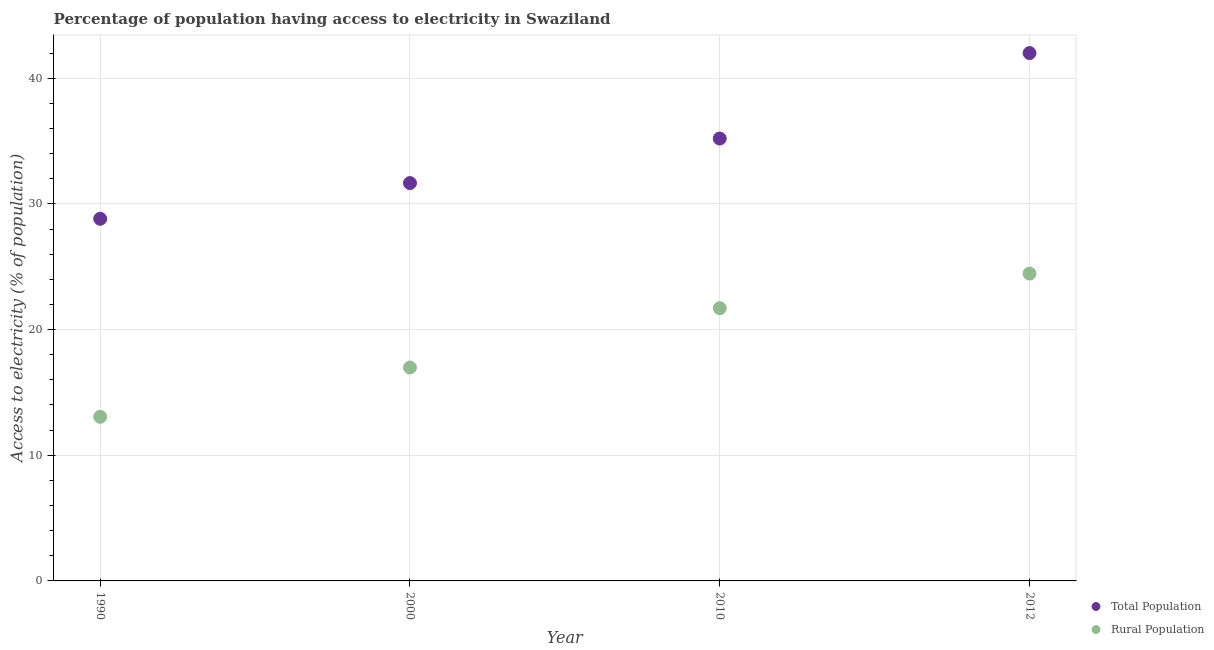How many different coloured dotlines are there?
Your answer should be compact. 2. What is the percentage of population having access to electricity in 1990?
Offer a very short reply. 28.82. Across all years, what is the maximum percentage of rural population having access to electricity?
Provide a short and direct response. 24.45. Across all years, what is the minimum percentage of rural population having access to electricity?
Ensure brevity in your answer.  13.06. In which year was the percentage of population having access to electricity maximum?
Keep it short and to the point. 2012. In which year was the percentage of rural population having access to electricity minimum?
Make the answer very short. 1990. What is the total percentage of population having access to electricity in the graph?
Your response must be concise. 137.67. What is the difference between the percentage of population having access to electricity in 2010 and that in 2012?
Offer a very short reply. -6.8. What is the difference between the percentage of rural population having access to electricity in 2010 and the percentage of population having access to electricity in 2012?
Keep it short and to the point. -20.3. What is the average percentage of population having access to electricity per year?
Offer a very short reply. 34.42. In the year 2012, what is the difference between the percentage of population having access to electricity and percentage of rural population having access to electricity?
Offer a terse response. 17.55. In how many years, is the percentage of population having access to electricity greater than 34 %?
Your answer should be compact. 2. What is the ratio of the percentage of population having access to electricity in 1990 to that in 2012?
Provide a succinct answer. 0.69. What is the difference between the highest and the second highest percentage of population having access to electricity?
Provide a short and direct response. 6.8. What is the difference between the highest and the lowest percentage of rural population having access to electricity?
Your response must be concise. 11.39. In how many years, is the percentage of population having access to electricity greater than the average percentage of population having access to electricity taken over all years?
Your answer should be compact. 2. Is the sum of the percentage of population having access to electricity in 1990 and 2012 greater than the maximum percentage of rural population having access to electricity across all years?
Ensure brevity in your answer.  Yes. Is the percentage of population having access to electricity strictly less than the percentage of rural population having access to electricity over the years?
Give a very brief answer. No. How many dotlines are there?
Make the answer very short. 2. How many years are there in the graph?
Offer a terse response. 4. Are the values on the major ticks of Y-axis written in scientific E-notation?
Your answer should be very brief. No. How many legend labels are there?
Your answer should be compact. 2. What is the title of the graph?
Your response must be concise. Percentage of population having access to electricity in Swaziland. What is the label or title of the Y-axis?
Your answer should be compact. Access to electricity (% of population). What is the Access to electricity (% of population) in Total Population in 1990?
Your answer should be compact. 28.82. What is the Access to electricity (% of population) in Rural Population in 1990?
Provide a succinct answer. 13.06. What is the Access to electricity (% of population) in Total Population in 2000?
Make the answer very short. 31.66. What is the Access to electricity (% of population) of Rural Population in 2000?
Give a very brief answer. 16.98. What is the Access to electricity (% of population) of Total Population in 2010?
Your response must be concise. 35.2. What is the Access to electricity (% of population) of Rural Population in 2010?
Your response must be concise. 21.7. What is the Access to electricity (% of population) of Total Population in 2012?
Provide a succinct answer. 42. What is the Access to electricity (% of population) in Rural Population in 2012?
Your response must be concise. 24.45. Across all years, what is the maximum Access to electricity (% of population) of Rural Population?
Your answer should be very brief. 24.45. Across all years, what is the minimum Access to electricity (% of population) in Total Population?
Provide a succinct answer. 28.82. Across all years, what is the minimum Access to electricity (% of population) in Rural Population?
Your response must be concise. 13.06. What is the total Access to electricity (% of population) in Total Population in the graph?
Provide a short and direct response. 137.67. What is the total Access to electricity (% of population) of Rural Population in the graph?
Keep it short and to the point. 76.2. What is the difference between the Access to electricity (% of population) in Total Population in 1990 and that in 2000?
Provide a short and direct response. -2.84. What is the difference between the Access to electricity (% of population) of Rural Population in 1990 and that in 2000?
Offer a very short reply. -3.92. What is the difference between the Access to electricity (% of population) in Total Population in 1990 and that in 2010?
Provide a succinct answer. -6.38. What is the difference between the Access to electricity (% of population) in Rural Population in 1990 and that in 2010?
Give a very brief answer. -8.64. What is the difference between the Access to electricity (% of population) of Total Population in 1990 and that in 2012?
Provide a short and direct response. -13.18. What is the difference between the Access to electricity (% of population) of Rural Population in 1990 and that in 2012?
Offer a terse response. -11.39. What is the difference between the Access to electricity (% of population) in Total Population in 2000 and that in 2010?
Make the answer very short. -3.54. What is the difference between the Access to electricity (% of population) of Rural Population in 2000 and that in 2010?
Ensure brevity in your answer.  -4.72. What is the difference between the Access to electricity (% of population) of Total Population in 2000 and that in 2012?
Provide a short and direct response. -10.34. What is the difference between the Access to electricity (% of population) in Rural Population in 2000 and that in 2012?
Give a very brief answer. -7.47. What is the difference between the Access to electricity (% of population) in Total Population in 2010 and that in 2012?
Your answer should be very brief. -6.8. What is the difference between the Access to electricity (% of population) in Rural Population in 2010 and that in 2012?
Keep it short and to the point. -2.75. What is the difference between the Access to electricity (% of population) in Total Population in 1990 and the Access to electricity (% of population) in Rural Population in 2000?
Your answer should be very brief. 11.84. What is the difference between the Access to electricity (% of population) in Total Population in 1990 and the Access to electricity (% of population) in Rural Population in 2010?
Your response must be concise. 7.12. What is the difference between the Access to electricity (% of population) in Total Population in 1990 and the Access to electricity (% of population) in Rural Population in 2012?
Offer a very short reply. 4.36. What is the difference between the Access to electricity (% of population) of Total Population in 2000 and the Access to electricity (% of population) of Rural Population in 2010?
Your answer should be very brief. 9.96. What is the difference between the Access to electricity (% of population) in Total Population in 2000 and the Access to electricity (% of population) in Rural Population in 2012?
Your response must be concise. 7.2. What is the difference between the Access to electricity (% of population) of Total Population in 2010 and the Access to electricity (% of population) of Rural Population in 2012?
Ensure brevity in your answer.  10.75. What is the average Access to electricity (% of population) in Total Population per year?
Offer a terse response. 34.42. What is the average Access to electricity (% of population) of Rural Population per year?
Keep it short and to the point. 19.05. In the year 1990, what is the difference between the Access to electricity (% of population) in Total Population and Access to electricity (% of population) in Rural Population?
Provide a succinct answer. 15.76. In the year 2000, what is the difference between the Access to electricity (% of population) in Total Population and Access to electricity (% of population) in Rural Population?
Your response must be concise. 14.68. In the year 2012, what is the difference between the Access to electricity (% of population) of Total Population and Access to electricity (% of population) of Rural Population?
Offer a very short reply. 17.55. What is the ratio of the Access to electricity (% of population) of Total Population in 1990 to that in 2000?
Provide a succinct answer. 0.91. What is the ratio of the Access to electricity (% of population) of Rural Population in 1990 to that in 2000?
Your answer should be very brief. 0.77. What is the ratio of the Access to electricity (% of population) of Total Population in 1990 to that in 2010?
Provide a short and direct response. 0.82. What is the ratio of the Access to electricity (% of population) in Rural Population in 1990 to that in 2010?
Your response must be concise. 0.6. What is the ratio of the Access to electricity (% of population) of Total Population in 1990 to that in 2012?
Ensure brevity in your answer.  0.69. What is the ratio of the Access to electricity (% of population) in Rural Population in 1990 to that in 2012?
Give a very brief answer. 0.53. What is the ratio of the Access to electricity (% of population) of Total Population in 2000 to that in 2010?
Offer a very short reply. 0.9. What is the ratio of the Access to electricity (% of population) in Rural Population in 2000 to that in 2010?
Provide a short and direct response. 0.78. What is the ratio of the Access to electricity (% of population) of Total Population in 2000 to that in 2012?
Ensure brevity in your answer.  0.75. What is the ratio of the Access to electricity (% of population) of Rural Population in 2000 to that in 2012?
Make the answer very short. 0.69. What is the ratio of the Access to electricity (% of population) of Total Population in 2010 to that in 2012?
Provide a short and direct response. 0.84. What is the ratio of the Access to electricity (% of population) of Rural Population in 2010 to that in 2012?
Offer a terse response. 0.89. What is the difference between the highest and the second highest Access to electricity (% of population) in Rural Population?
Your answer should be compact. 2.75. What is the difference between the highest and the lowest Access to electricity (% of population) of Total Population?
Make the answer very short. 13.18. What is the difference between the highest and the lowest Access to electricity (% of population) in Rural Population?
Give a very brief answer. 11.39. 